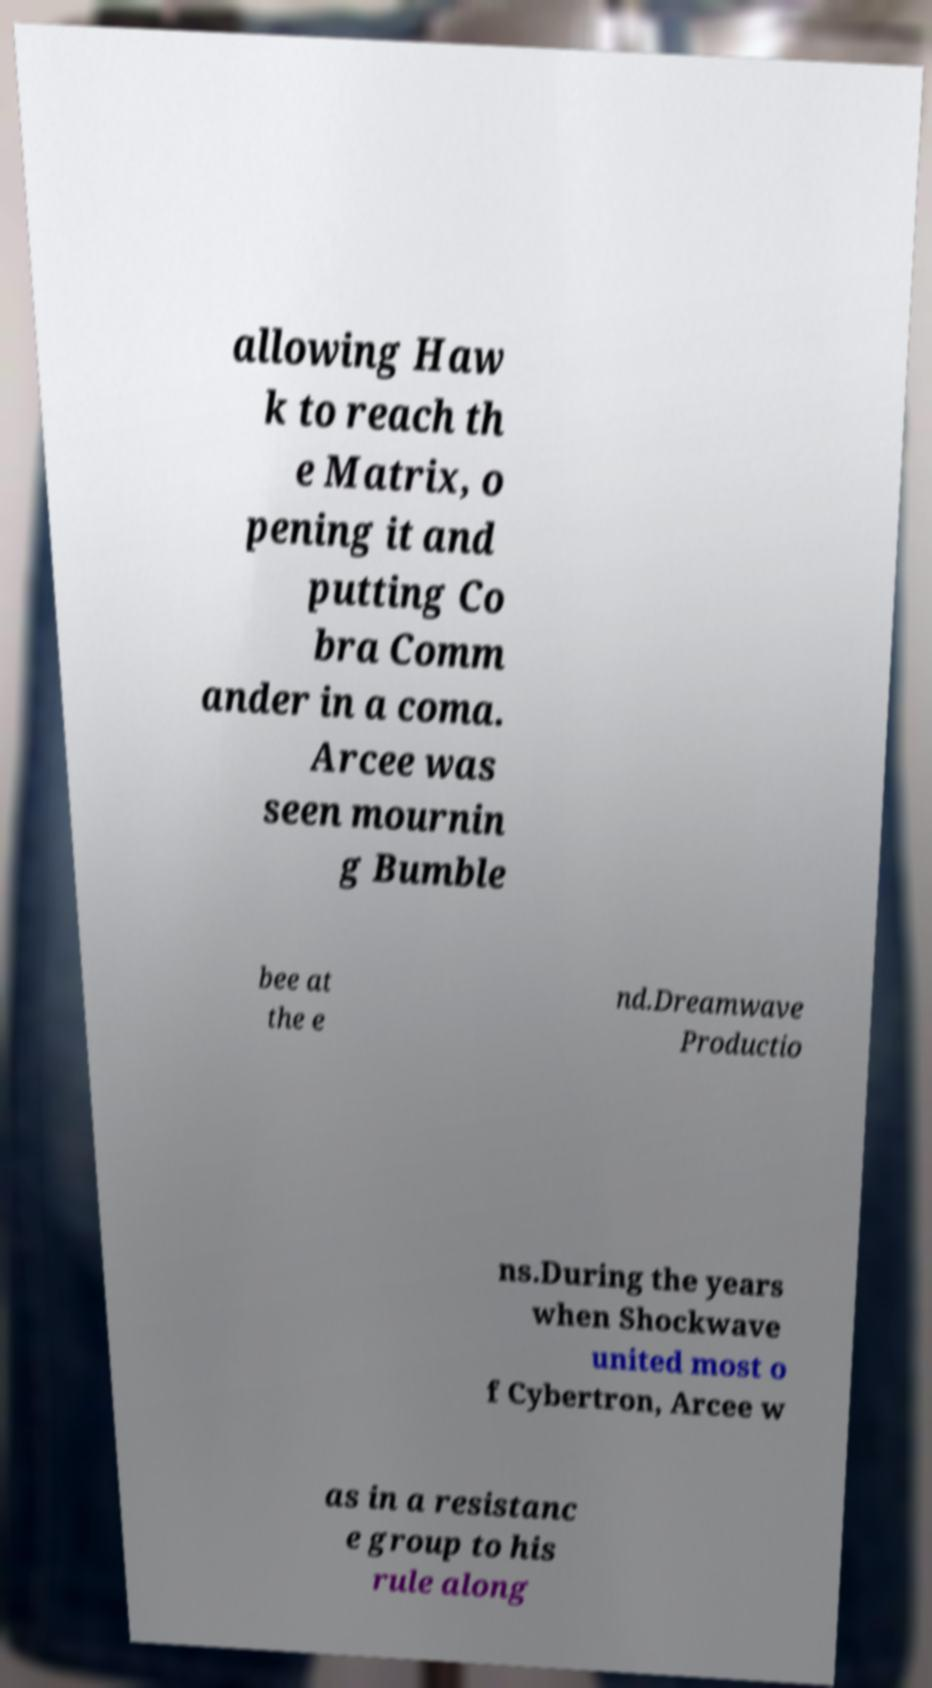Please identify and transcribe the text found in this image. allowing Haw k to reach th e Matrix, o pening it and putting Co bra Comm ander in a coma. Arcee was seen mournin g Bumble bee at the e nd.Dreamwave Productio ns.During the years when Shockwave united most o f Cybertron, Arcee w as in a resistanc e group to his rule along 